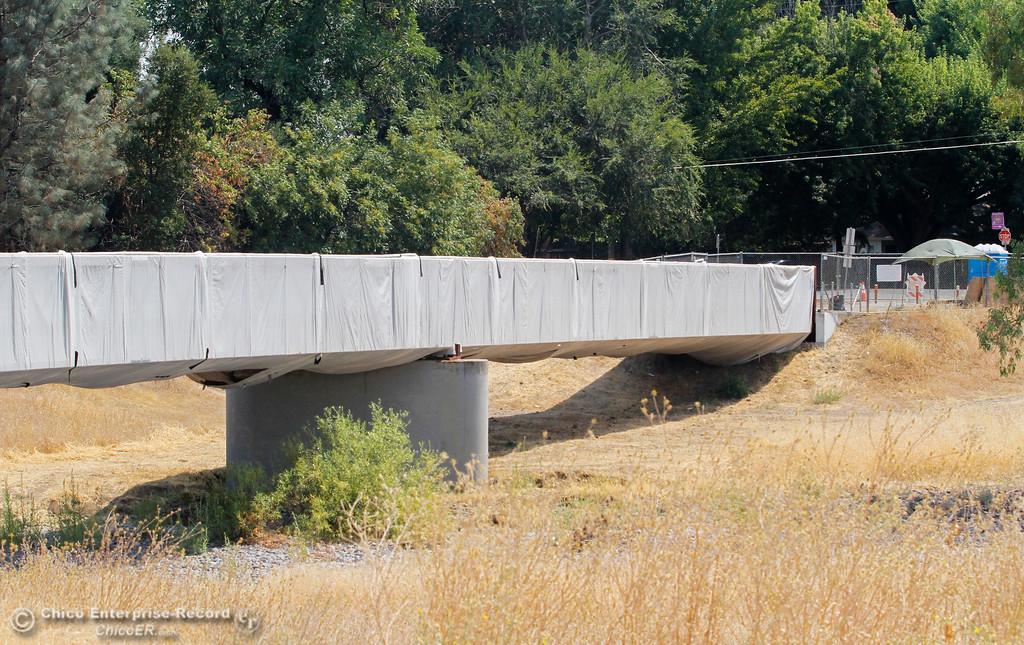Can you explain why the bridge work might be scheduled during a specific season or time of day? The timing of bridge work might be strategically planned based on environmental and safety considerations. Conducting work during specific seasons can avoid extreme weather conditions, ensuring the safety of workers and efficiency of the project. Milder temperatures can aid in certain processes like curing of concrete or asphalt laying. Scheduling work during daytime off-peak hours reduces disruptions to traffic and maximizes daylight hours for visibility and productivity, while night work might be considered to minimize traffic congestion when necessary. 